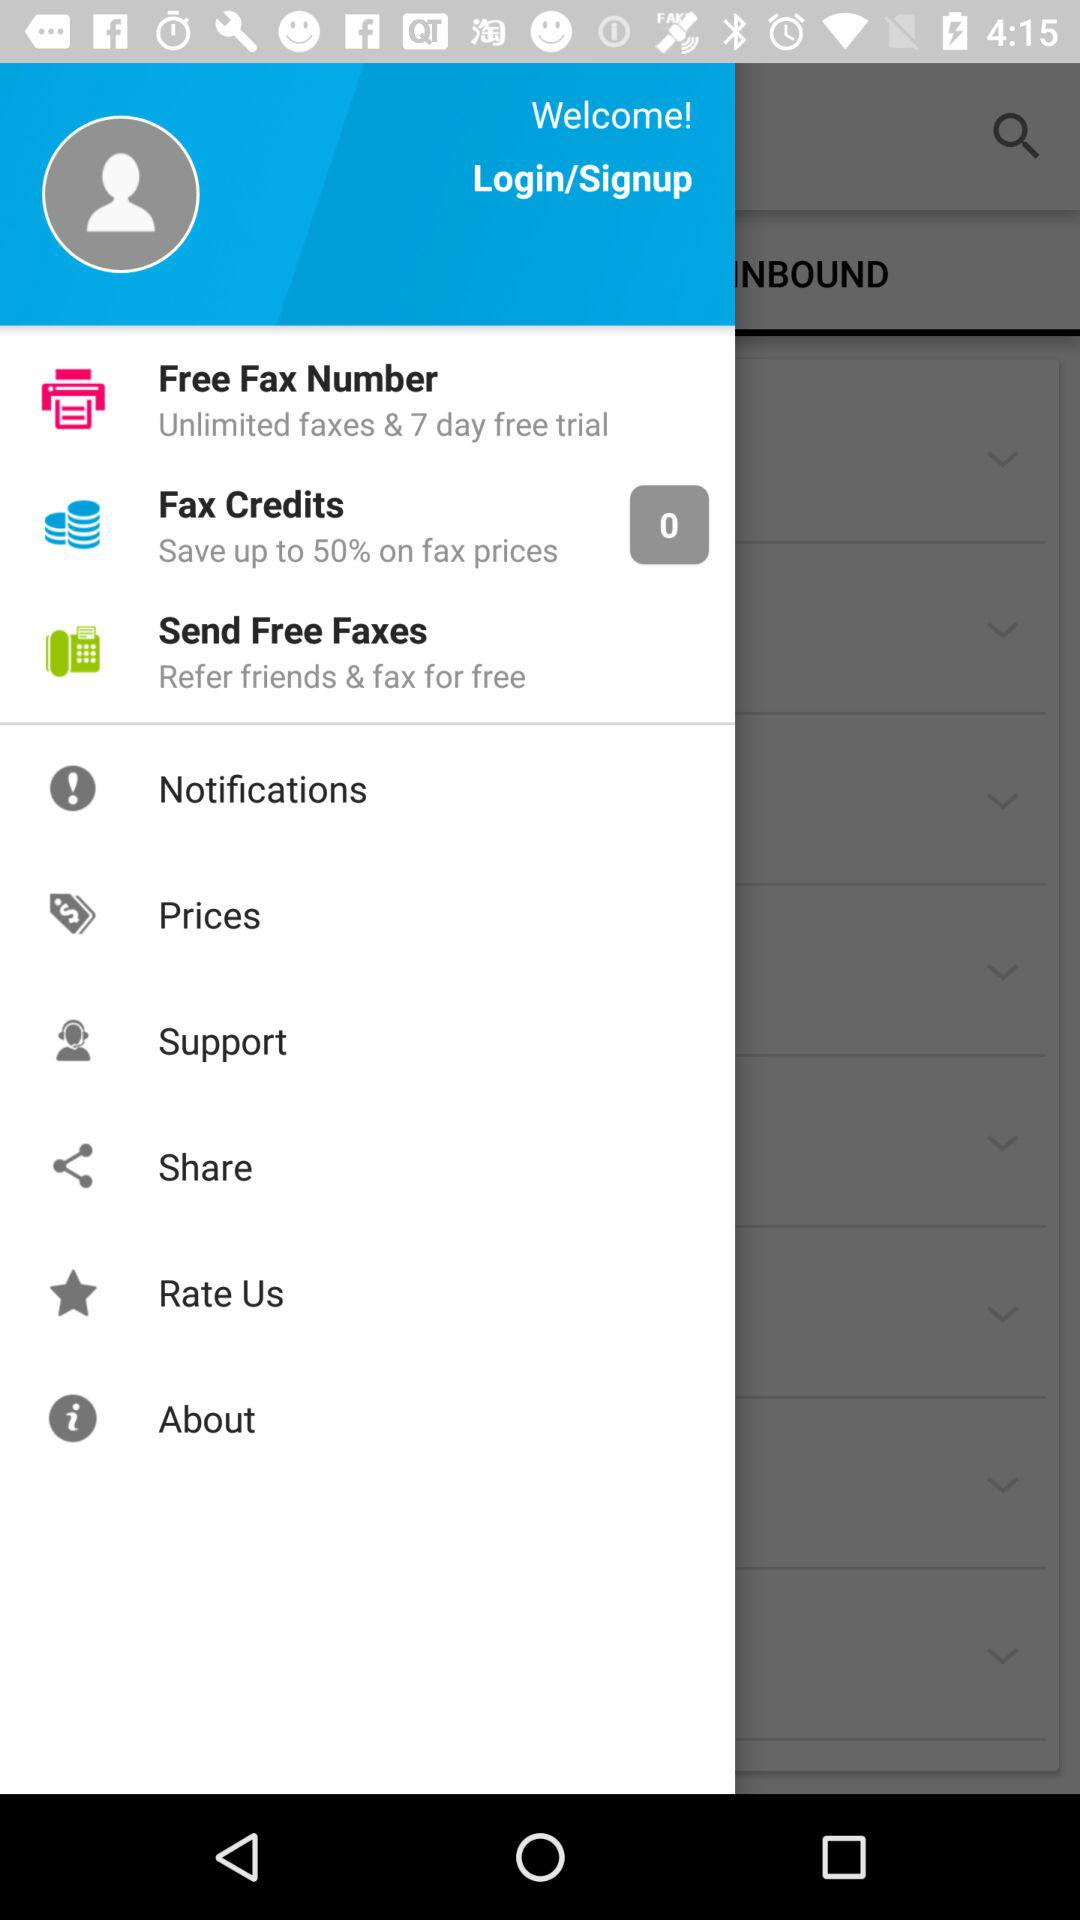How much can we save on fax prices? You can save up to 50% on fax prices. 